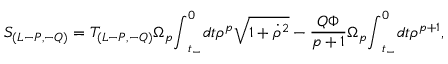<formula> <loc_0><loc_0><loc_500><loc_500>S _ { ( L - P , - Q ) } = T _ { ( L - P , - Q ) } { \Omega } _ { p } { \int } _ { t _ { - } } ^ { 0 } d t { \rho } ^ { p } \sqrt { 1 + { \dot { \rho } } ^ { 2 } } - \frac { Q { \Phi } } { p + 1 } { \Omega } _ { p } { \int } _ { t _ { - } } ^ { 0 } d t { \rho } ^ { p + 1 } ,</formula> 